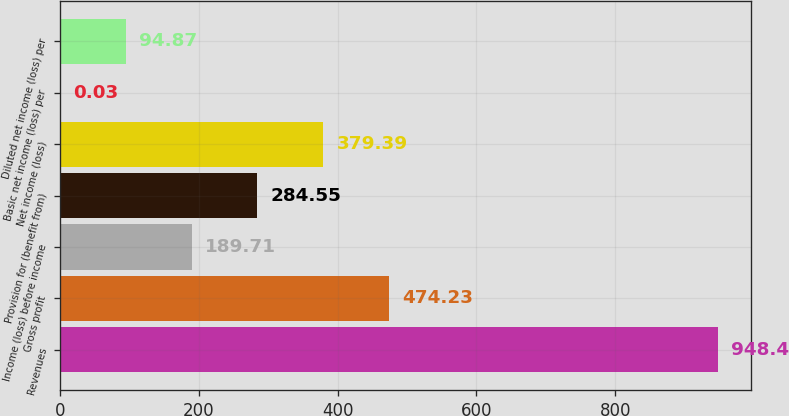<chart> <loc_0><loc_0><loc_500><loc_500><bar_chart><fcel>Revenues<fcel>Gross profit<fcel>Income (loss) before income<fcel>Provision for (benefit from)<fcel>Net income (loss)<fcel>Basic net income (loss) per<fcel>Diluted net income (loss) per<nl><fcel>948.4<fcel>474.23<fcel>189.71<fcel>284.55<fcel>379.39<fcel>0.03<fcel>94.87<nl></chart> 